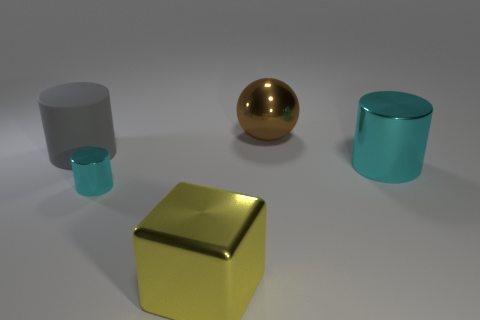Add 3 big yellow objects. How many objects exist? 8 Subtract all cylinders. How many objects are left? 2 Add 1 shiny cylinders. How many shiny cylinders are left? 3 Add 4 shiny things. How many shiny things exist? 8 Subtract 0 green spheres. How many objects are left? 5 Subtract all small cylinders. Subtract all big rubber cylinders. How many objects are left? 3 